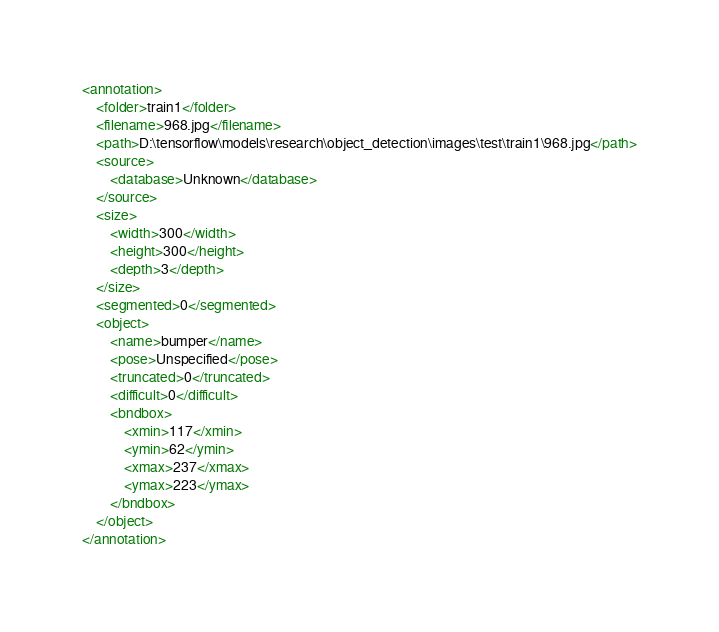<code> <loc_0><loc_0><loc_500><loc_500><_XML_><annotation>
	<folder>train1</folder>
	<filename>968.jpg</filename>
	<path>D:\tensorflow\models\research\object_detection\images\test\train1\968.jpg</path>
	<source>
		<database>Unknown</database>
	</source>
	<size>
		<width>300</width>
		<height>300</height>
		<depth>3</depth>
	</size>
	<segmented>0</segmented>
	<object>
		<name>bumper</name>
		<pose>Unspecified</pose>
		<truncated>0</truncated>
		<difficult>0</difficult>
		<bndbox>
			<xmin>117</xmin>
			<ymin>62</ymin>
			<xmax>237</xmax>
			<ymax>223</ymax>
		</bndbox>
	</object>
</annotation>
</code> 